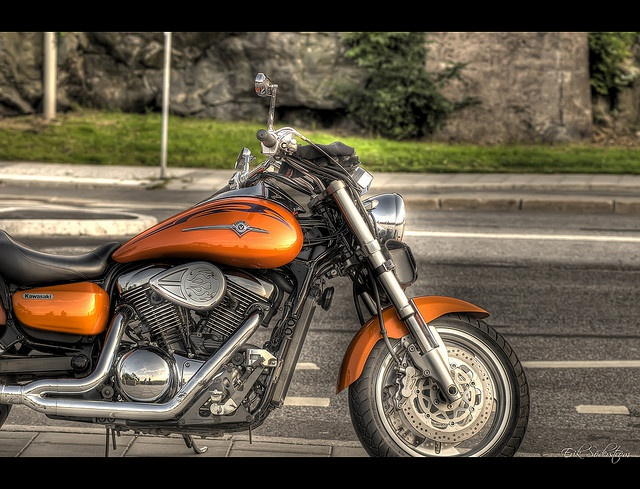Describe the objects in this image and their specific colors. I can see a motorcycle in black, gray, darkgray, and ivory tones in this image. 